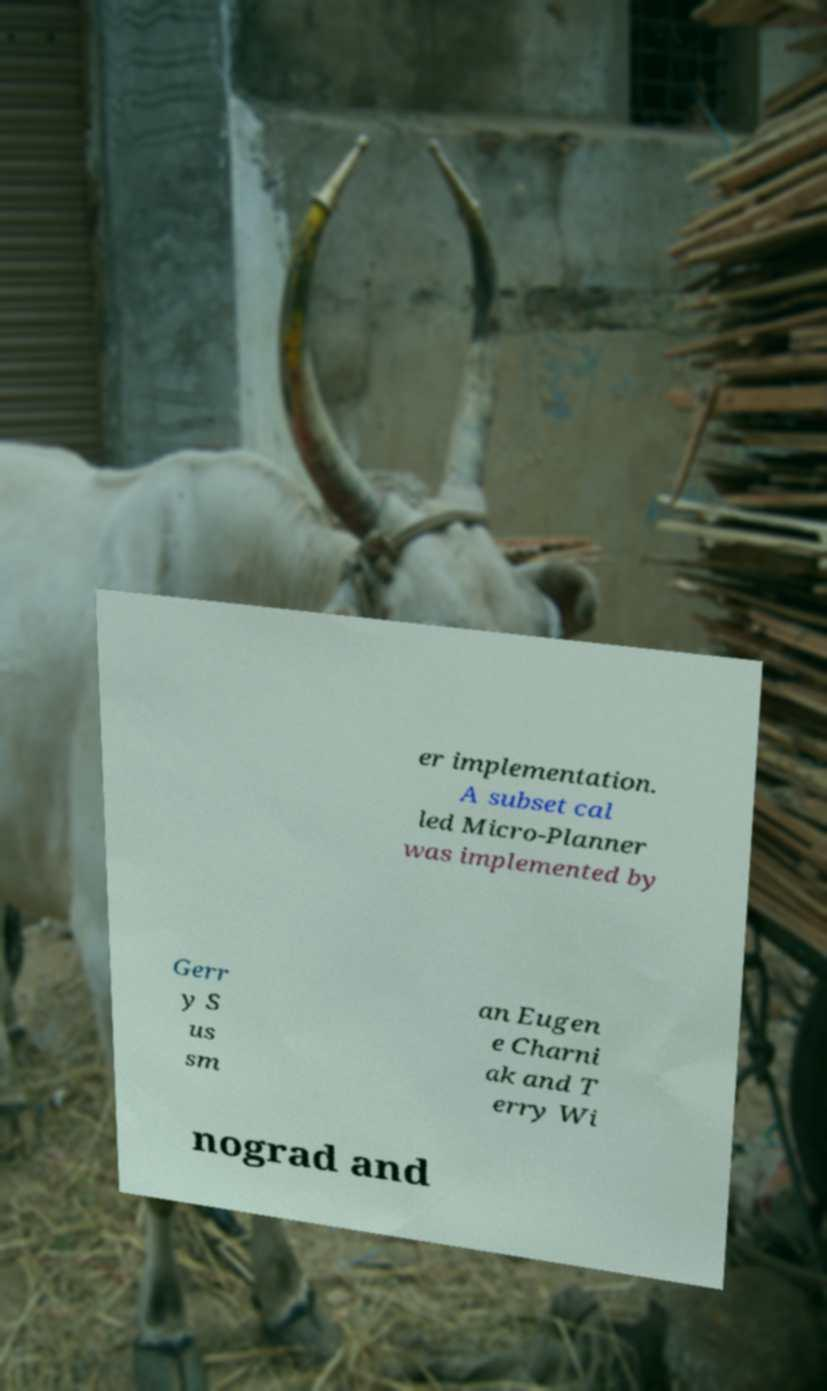Please identify and transcribe the text found in this image. er implementation. A subset cal led Micro-Planner was implemented by Gerr y S us sm an Eugen e Charni ak and T erry Wi nograd and 